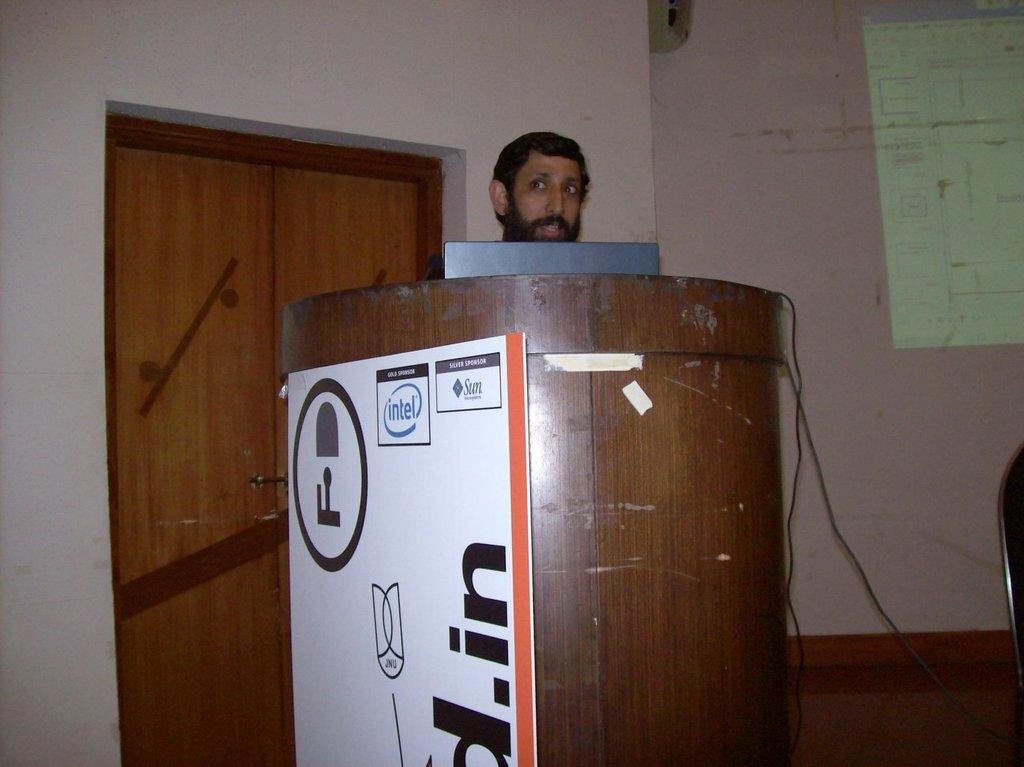Provide a one-sentence caption for the provided image. A man stands behind a podium with an intel logo on the side. 